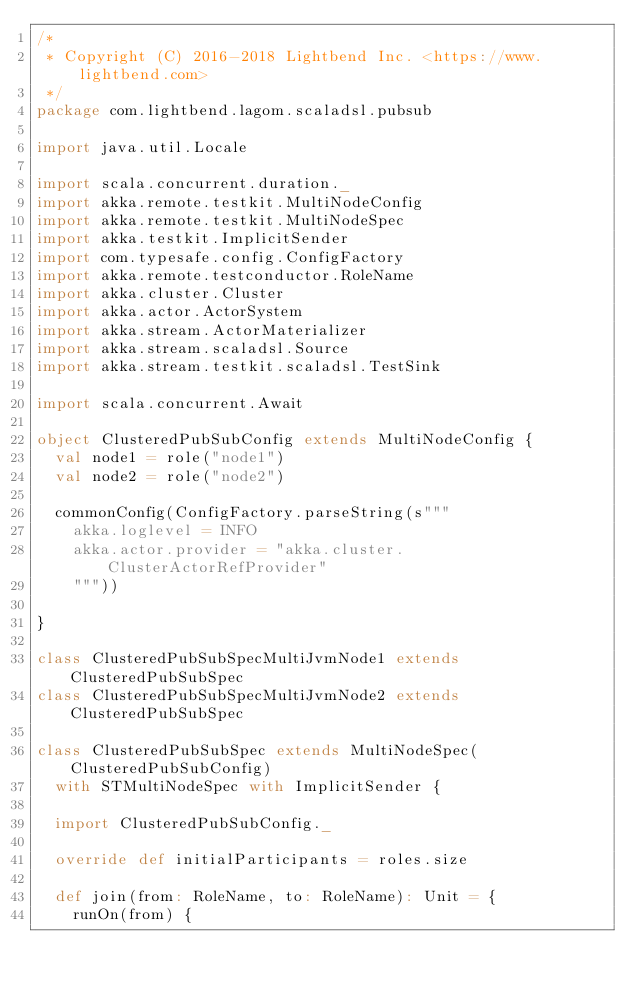<code> <loc_0><loc_0><loc_500><loc_500><_Scala_>/*
 * Copyright (C) 2016-2018 Lightbend Inc. <https://www.lightbend.com>
 */
package com.lightbend.lagom.scaladsl.pubsub

import java.util.Locale

import scala.concurrent.duration._
import akka.remote.testkit.MultiNodeConfig
import akka.remote.testkit.MultiNodeSpec
import akka.testkit.ImplicitSender
import com.typesafe.config.ConfigFactory
import akka.remote.testconductor.RoleName
import akka.cluster.Cluster
import akka.actor.ActorSystem
import akka.stream.ActorMaterializer
import akka.stream.scaladsl.Source
import akka.stream.testkit.scaladsl.TestSink

import scala.concurrent.Await

object ClusteredPubSubConfig extends MultiNodeConfig {
  val node1 = role("node1")
  val node2 = role("node2")

  commonConfig(ConfigFactory.parseString(s"""
    akka.loglevel = INFO
    akka.actor.provider = "akka.cluster.ClusterActorRefProvider"
    """))

}

class ClusteredPubSubSpecMultiJvmNode1 extends ClusteredPubSubSpec
class ClusteredPubSubSpecMultiJvmNode2 extends ClusteredPubSubSpec

class ClusteredPubSubSpec extends MultiNodeSpec(ClusteredPubSubConfig)
  with STMultiNodeSpec with ImplicitSender {

  import ClusteredPubSubConfig._

  override def initialParticipants = roles.size

  def join(from: RoleName, to: RoleName): Unit = {
    runOn(from) {</code> 